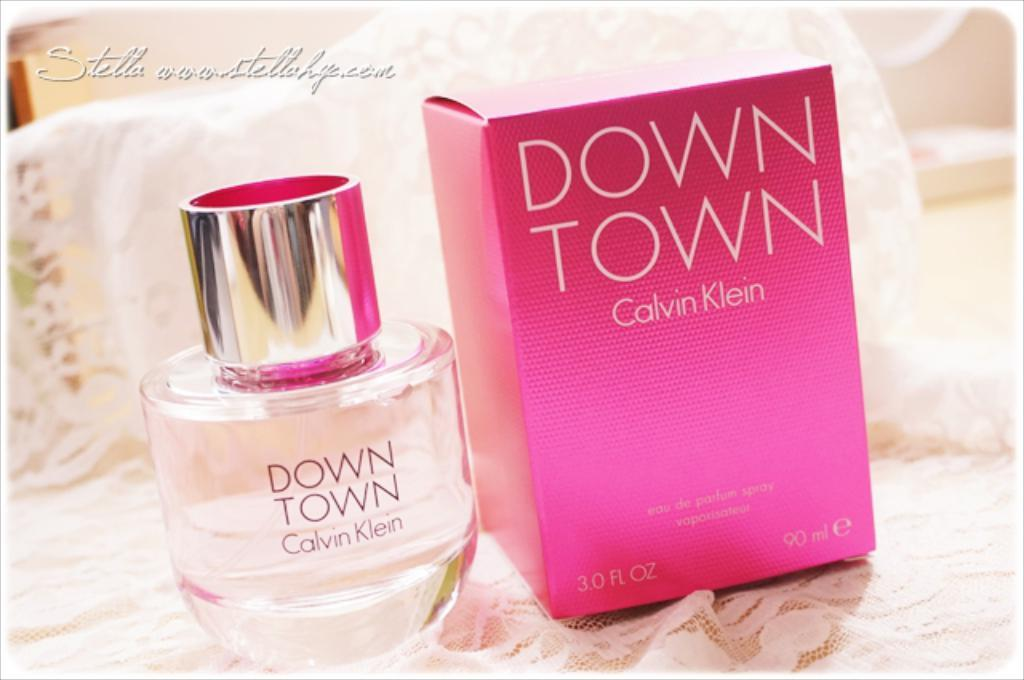<image>
Summarize the visual content of the image. A bottle of Down Town by Calvin Klein next to the box it came in. 